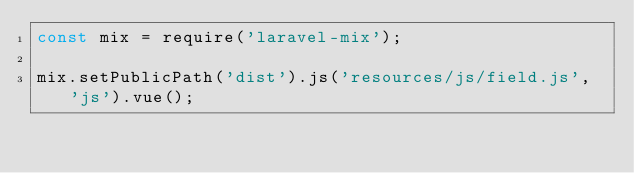Convert code to text. <code><loc_0><loc_0><loc_500><loc_500><_JavaScript_>const mix = require('laravel-mix');

mix.setPublicPath('dist').js('resources/js/field.js', 'js').vue();
</code> 